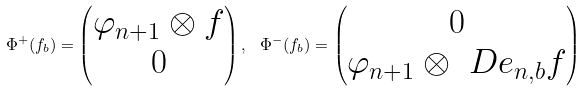Convert formula to latex. <formula><loc_0><loc_0><loc_500><loc_500>\Phi ^ { + } ( f _ { b } ) = \begin{pmatrix} \varphi _ { n + 1 } \otimes f \\ 0 \end{pmatrix} , \ \Phi ^ { - } ( f _ { b } ) = \begin{pmatrix} 0 \\ \varphi _ { n + 1 } \otimes \ D e _ { n , b } f \end{pmatrix}</formula> 